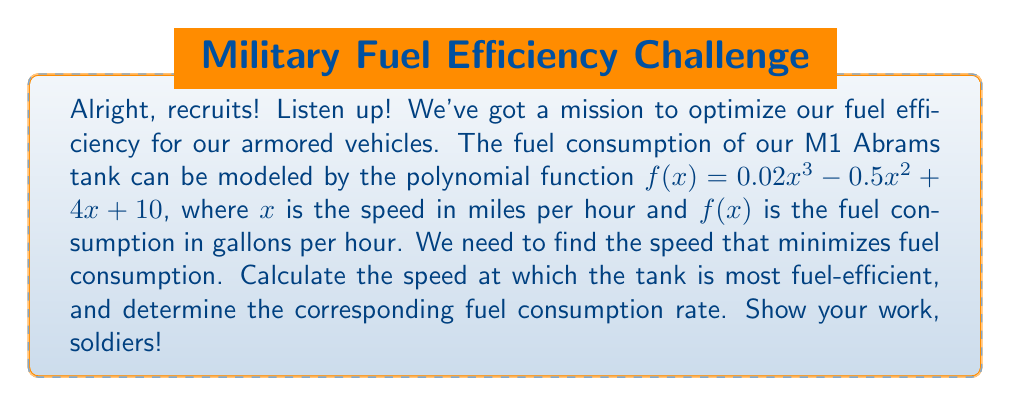Help me with this question. To find the speed that minimizes fuel consumption, we need to follow these steps:

1. Find the derivative of the fuel consumption function:
   $$f'(x) = 0.06x^2 - x + 4$$

2. Set the derivative equal to zero to find critical points:
   $$0.06x^2 - x + 4 = 0$$

3. Solve the quadratic equation:
   $$0.06x^2 - x + 4 = 0$$
   $$a = 0.06, b = -1, c = 4$$
   $$x = \frac{-b \pm \sqrt{b^2 - 4ac}}{2a}$$
   $$x = \frac{1 \pm \sqrt{1 - 4(0.06)(4)}}{2(0.06)}$$
   $$x = \frac{1 \pm \sqrt{1 - 0.96}}{0.12}$$
   $$x = \frac{1 \pm \sqrt{0.04}}{0.12}$$
   $$x = \frac{1 \pm 0.2}{0.12}$$

   This gives us two critical points:
   $$x_1 = \frac{1 + 0.2}{0.12} \approx 10$$
   $$x_2 = \frac{1 - 0.2}{0.12} \approx 6.67$$

4. Check the second derivative to confirm the minimum:
   $$f''(x) = 0.12x - 1$$
   At $x = 10$: $f''(10) = 0.12(10) - 1 = 0.2 > 0$ (local minimum)
   At $x = 6.67$: $f''(6.67) = 0.12(6.67) - 1 = -0.2 < 0$ (local maximum)

5. Calculate the fuel consumption at the minimum point:
   $$f(10) = 0.02(10^3) - 0.5(10^2) + 4(10) + 10$$
   $$f(10) = 20 - 50 + 40 + 10 = 20$$

Therefore, the tank is most fuel-efficient at approximately 10 mph, consuming about 20 gallons per hour.
Answer: 10 mph, 20 gallons/hour 